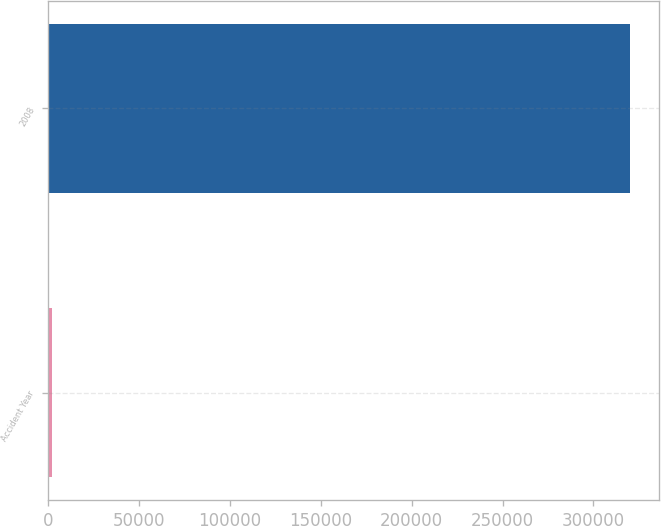<chart> <loc_0><loc_0><loc_500><loc_500><bar_chart><fcel>Accident Year<fcel>2008<nl><fcel>2012<fcel>320169<nl></chart> 